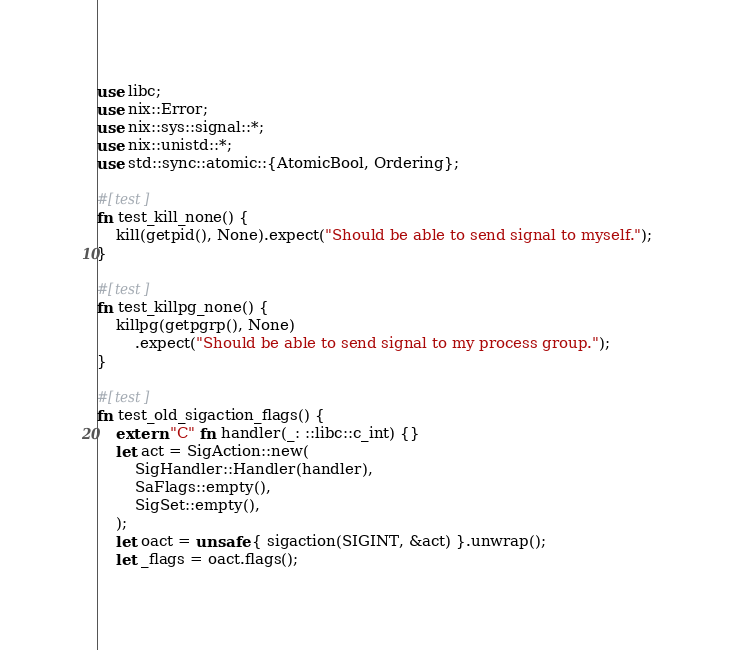Convert code to text. <code><loc_0><loc_0><loc_500><loc_500><_Rust_>use libc;
use nix::Error;
use nix::sys::signal::*;
use nix::unistd::*;
use std::sync::atomic::{AtomicBool, Ordering};

#[test]
fn test_kill_none() {
    kill(getpid(), None).expect("Should be able to send signal to myself.");
}

#[test]
fn test_killpg_none() {
    killpg(getpgrp(), None)
        .expect("Should be able to send signal to my process group.");
}

#[test]
fn test_old_sigaction_flags() {
    extern "C" fn handler(_: ::libc::c_int) {}
    let act = SigAction::new(
        SigHandler::Handler(handler),
        SaFlags::empty(),
        SigSet::empty(),
    );
    let oact = unsafe { sigaction(SIGINT, &act) }.unwrap();
    let _flags = oact.flags();</code> 